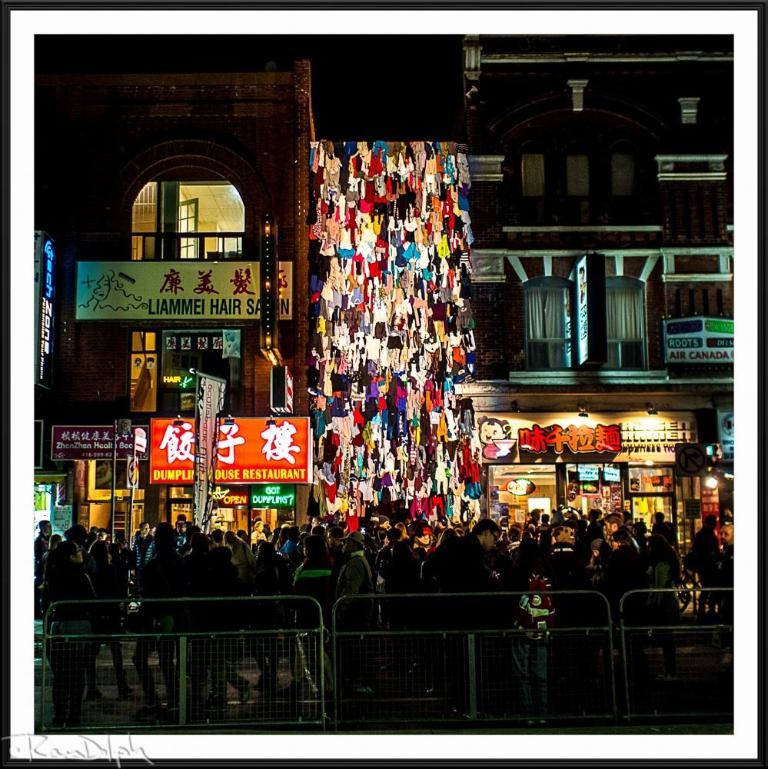What type of barrier is visible in the image? There is a fence in the image. What is happening at the bottom of the image? There is a crowd at the bottom of the image. What can be seen in the distance in the image? There are buildings in the background of the image. What type of material is the canvas made of in the image? There is no canvas present in the image. How is the wax being used in the image? There is no wax present in the image. 